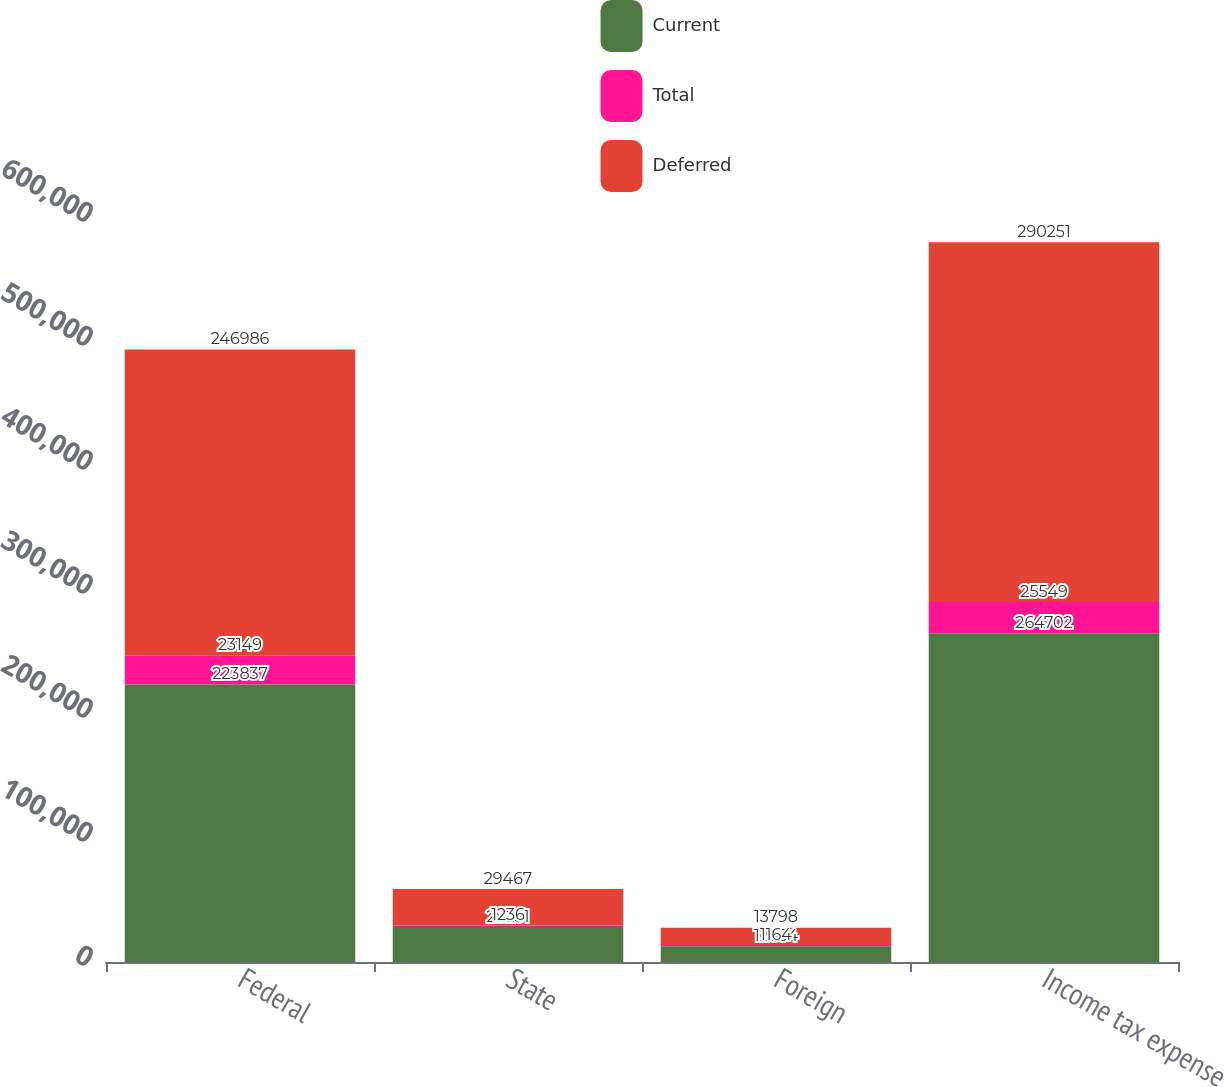<chart> <loc_0><loc_0><loc_500><loc_500><stacked_bar_chart><ecel><fcel>Federal<fcel>State<fcel>Foreign<fcel>Income tax expense<nl><fcel>Current<fcel>223837<fcel>28231<fcel>12634<fcel>264702<nl><fcel>Total<fcel>23149<fcel>1236<fcel>1164<fcel>25549<nl><fcel>Deferred<fcel>246986<fcel>29467<fcel>13798<fcel>290251<nl></chart> 